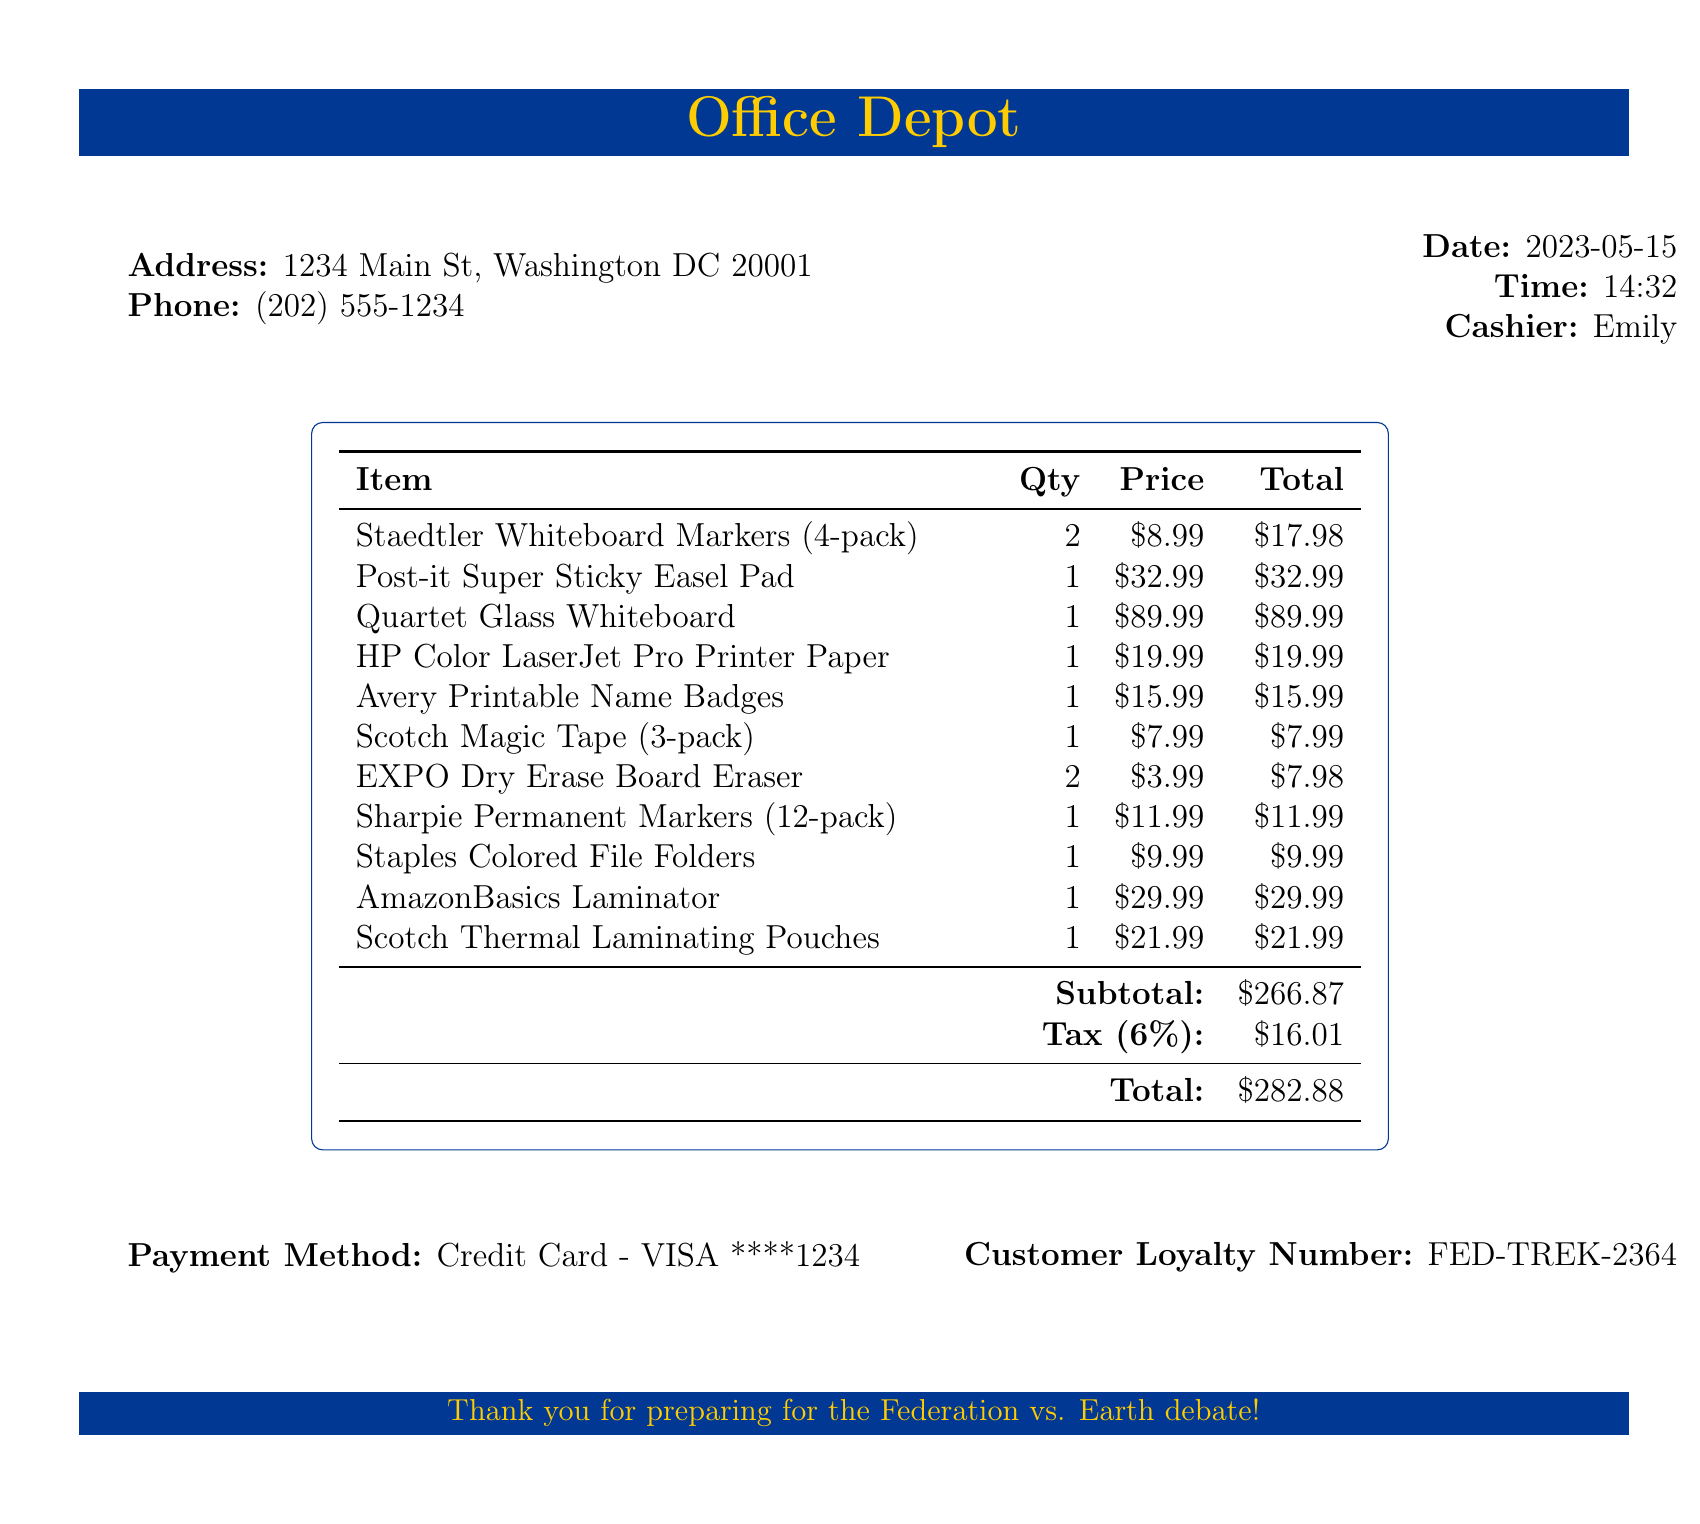what is the store name? The store name is explicitly listed at the beginning of the document.
Answer: Office Depot who was the cashier? The cashier's name is mentioned in a specific section of the receipt.
Answer: Emily what is the date of purchase? The date of purchase is clearly stated on the receipt.
Answer: 2023-05-15 how many items are listed in total? The total number of items can be counted from the receipt.
Answer: 11 what is the subtotal amount? The subtotal amount is provided in the summary section of the receipt.
Answer: $266.87 what is the total including tax? The total amount that includes tax is displayed at the end of the document.
Answer: $282.88 what payment method was used? The payment method is specified in a particular part of the receipt.
Answer: Credit Card - VISA ****1234 what is the tax rate applied? The tax rate is stated in a clear section of the receipt before calculating tax.
Answer: 6% what type of document is this? The structure and the items detailed in the document indicate that it is a sales receipt.
Answer: Receipt what is the customer loyalty number? The customer loyalty number is found in a designated area at the end of the receipt.
Answer: FED-TREK-2364 